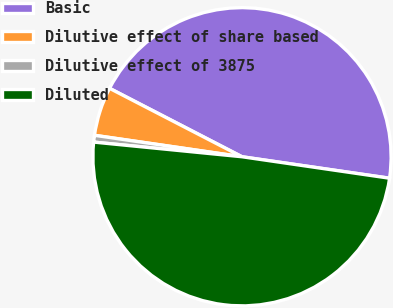Convert chart. <chart><loc_0><loc_0><loc_500><loc_500><pie_chart><fcel>Basic<fcel>Dilutive effect of share based<fcel>Dilutive effect of 3875<fcel>Diluted<nl><fcel>44.71%<fcel>5.29%<fcel>0.73%<fcel>49.27%<nl></chart> 